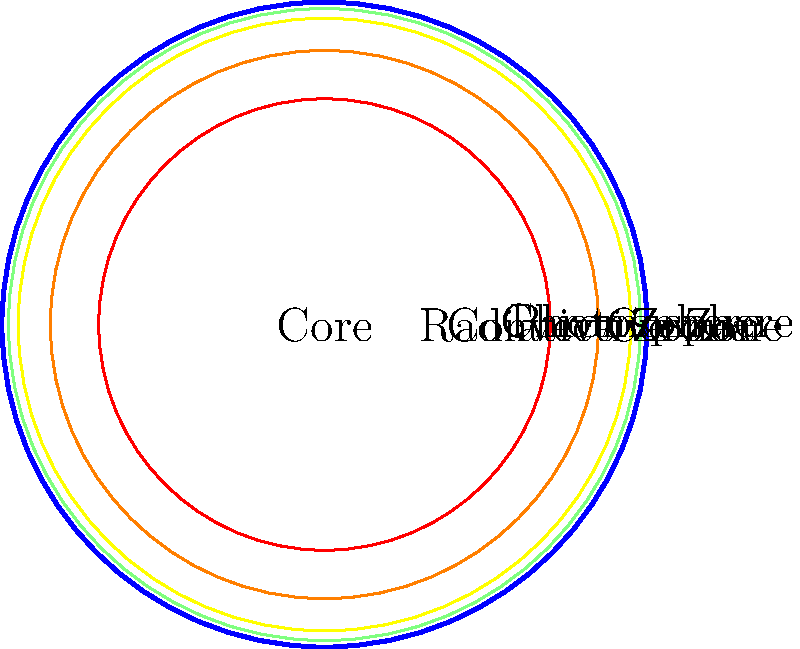En tant que future médecin, vous pourriez être amenée à traiter des patients souffrant de brûlures dues à l'exposition solaire. Quelle couche du Soleil est principalement responsable de la lumière visible que nous observons et qui peut causer ces brûlures ? Pour répondre à cette question, examinons les différentes couches du Soleil, de l'intérieur vers l'extérieur :

1. Le noyau : C'est le centre du Soleil où se produisent les réactions de fusion nucléaire.

2. La zone radiative : La chaleur et l'énergie du noyau sont transférées vers l'extérieur par radiation.

3. La zone convective : L'énergie est transportée par convection.

4. La photosphère : C'est la "surface" visible du Soleil. Elle émet la majorité de la lumière visible que nous observons.

5. La chromosphère : Une couche mince au-dessus de la photosphère, visible lors des éclipses solaires.

6. La couronne : La couche la plus externe de l'atmosphère solaire, visible lors des éclipses totales.

La photosphère est la couche qui émet la majorité de la lumière visible du Soleil. C'est cette lumière qui atteint la Terre et peut causer des brûlures solaires. Bien que les autres couches contribuent à l'émission totale du Soleil, la photosphère est la principale source de lumière visible et donc la réponse à notre question.
Answer: La photosphère 